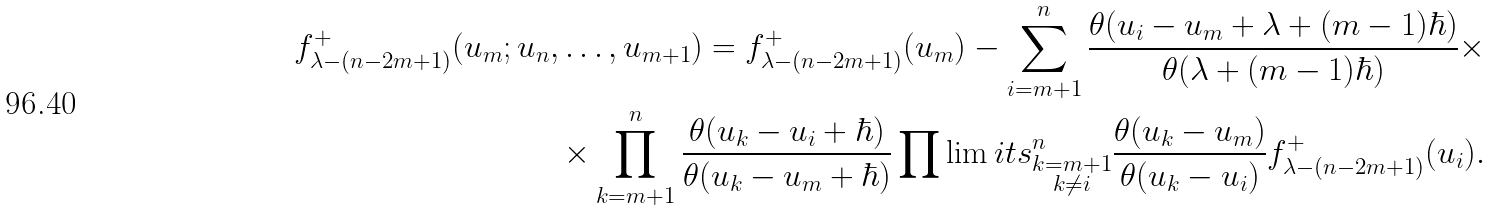<formula> <loc_0><loc_0><loc_500><loc_500>f ^ { + } _ { \lambda - ( n - 2 m + 1 ) } ( u _ { m } ; u _ { n } , \dots , u _ { m + 1 } ) = f ^ { + } _ { \lambda - ( n - 2 m + 1 ) } ( u _ { m } ) - \sum _ { i = m + 1 } ^ { n } \frac { \theta ( u _ { i } - u _ { m } + \lambda + ( m - 1 ) \hbar { ) } } { \theta ( \lambda + ( m - 1 ) \hbar { ) } } \times \\ \times \prod _ { k = m + 1 } ^ { n } \frac { \theta ( u _ { k } - u _ { i } + \hbar { ) } } { \theta ( u _ { k } - u _ { m } + \hbar { ) } } \prod \lim i t s _ { \substack { k = m + 1 \\ k \ne i } } ^ { n } \frac { \theta ( u _ { k } - u _ { m } ) } { \theta ( u _ { k } - u _ { i } ) } f ^ { + } _ { \lambda - ( n - 2 m + 1 ) } ( u _ { i } ) .</formula> 